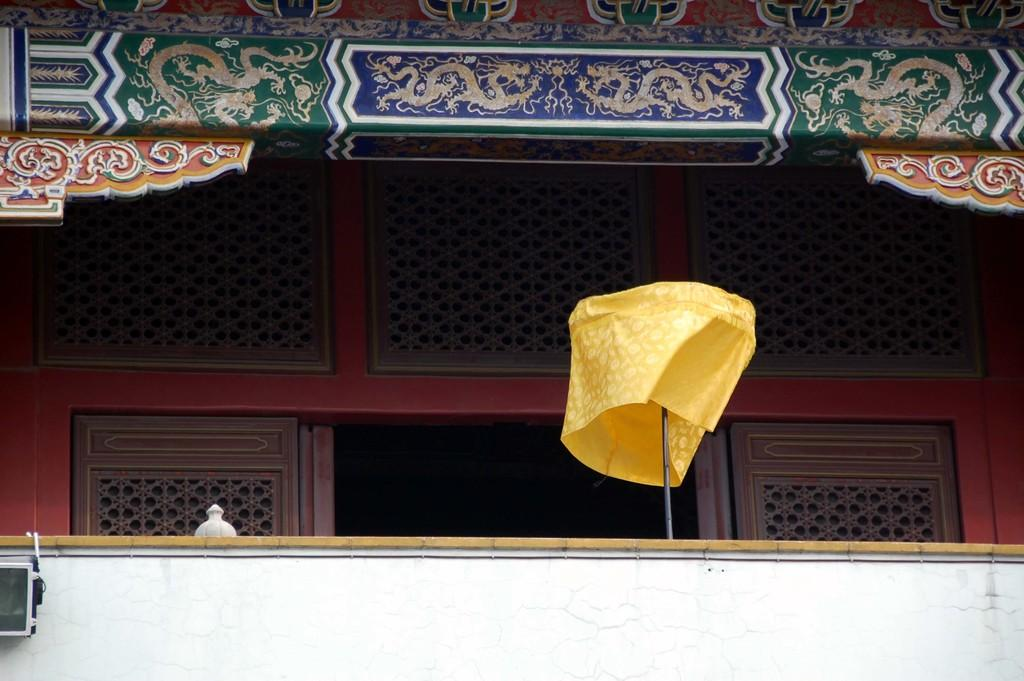What is the main subject of the image? The main subject of the image is a building. Can you describe the wall at the bottom of the building? There is a wall at the bottom of the building. What type of wall is visible in the background? There is a wooden wall in the background. What decorations can be seen on the wall at the top of the building? There are colorful paintings on the wall at the top of the building. How many pizzas are being raked in the image? There are no pizzas or rakes present in the image. What type of crack is visible on the wooden wall in the background? There is no crack visible on the wooden wall in the background; it is a solid wooden wall. 